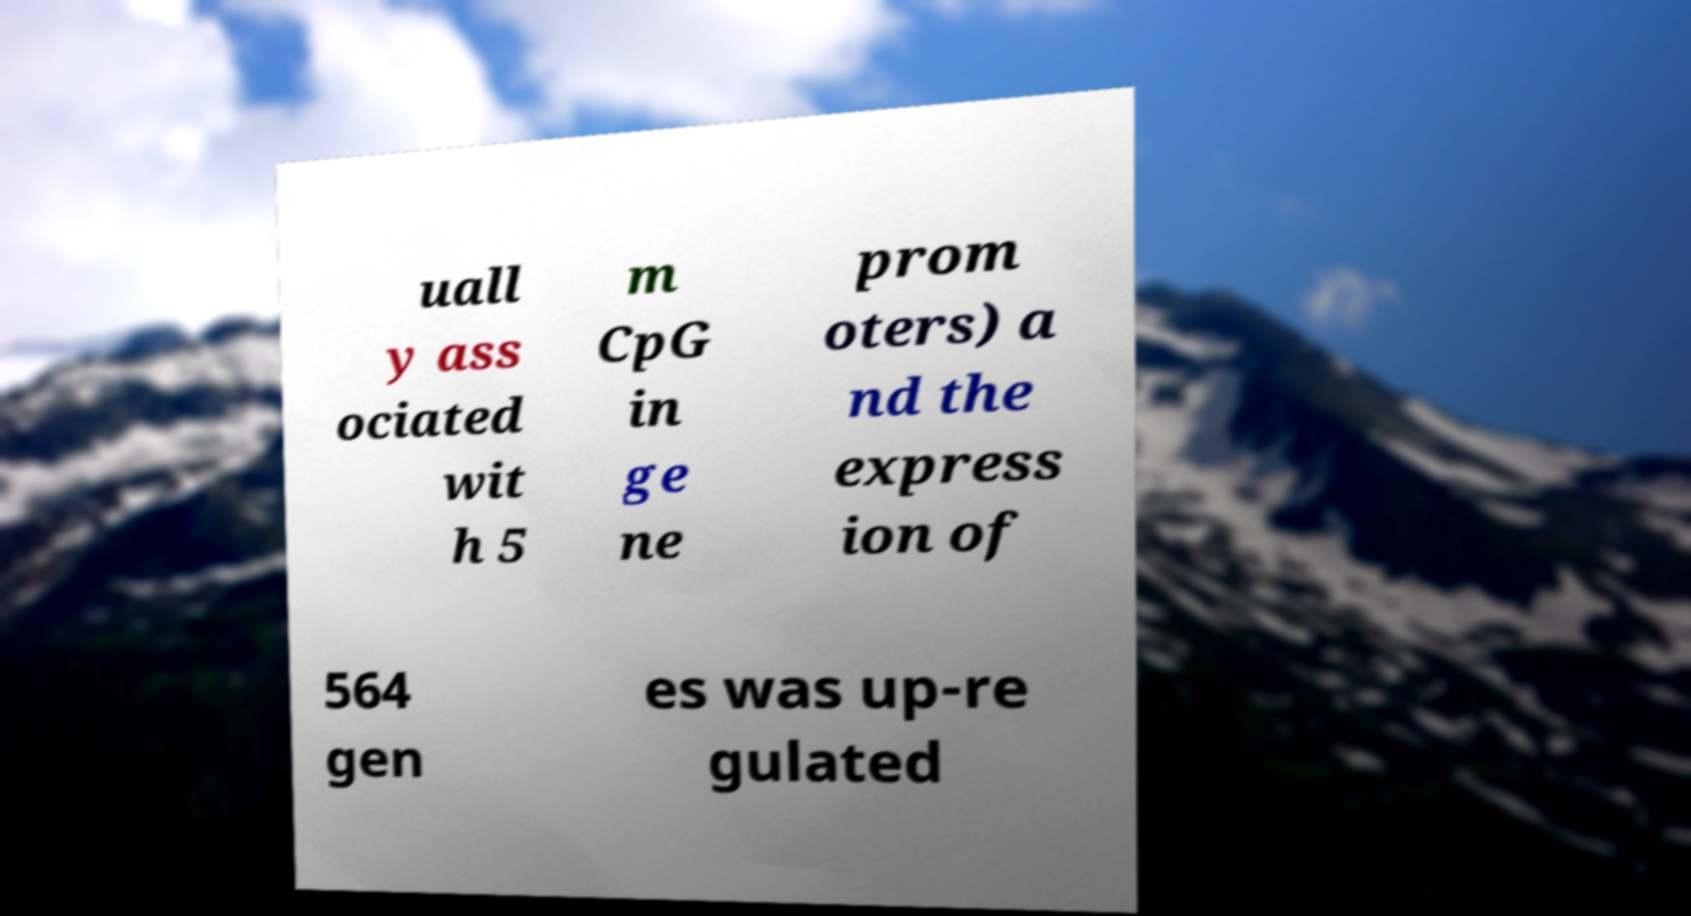For documentation purposes, I need the text within this image transcribed. Could you provide that? uall y ass ociated wit h 5 m CpG in ge ne prom oters) a nd the express ion of 564 gen es was up-re gulated 